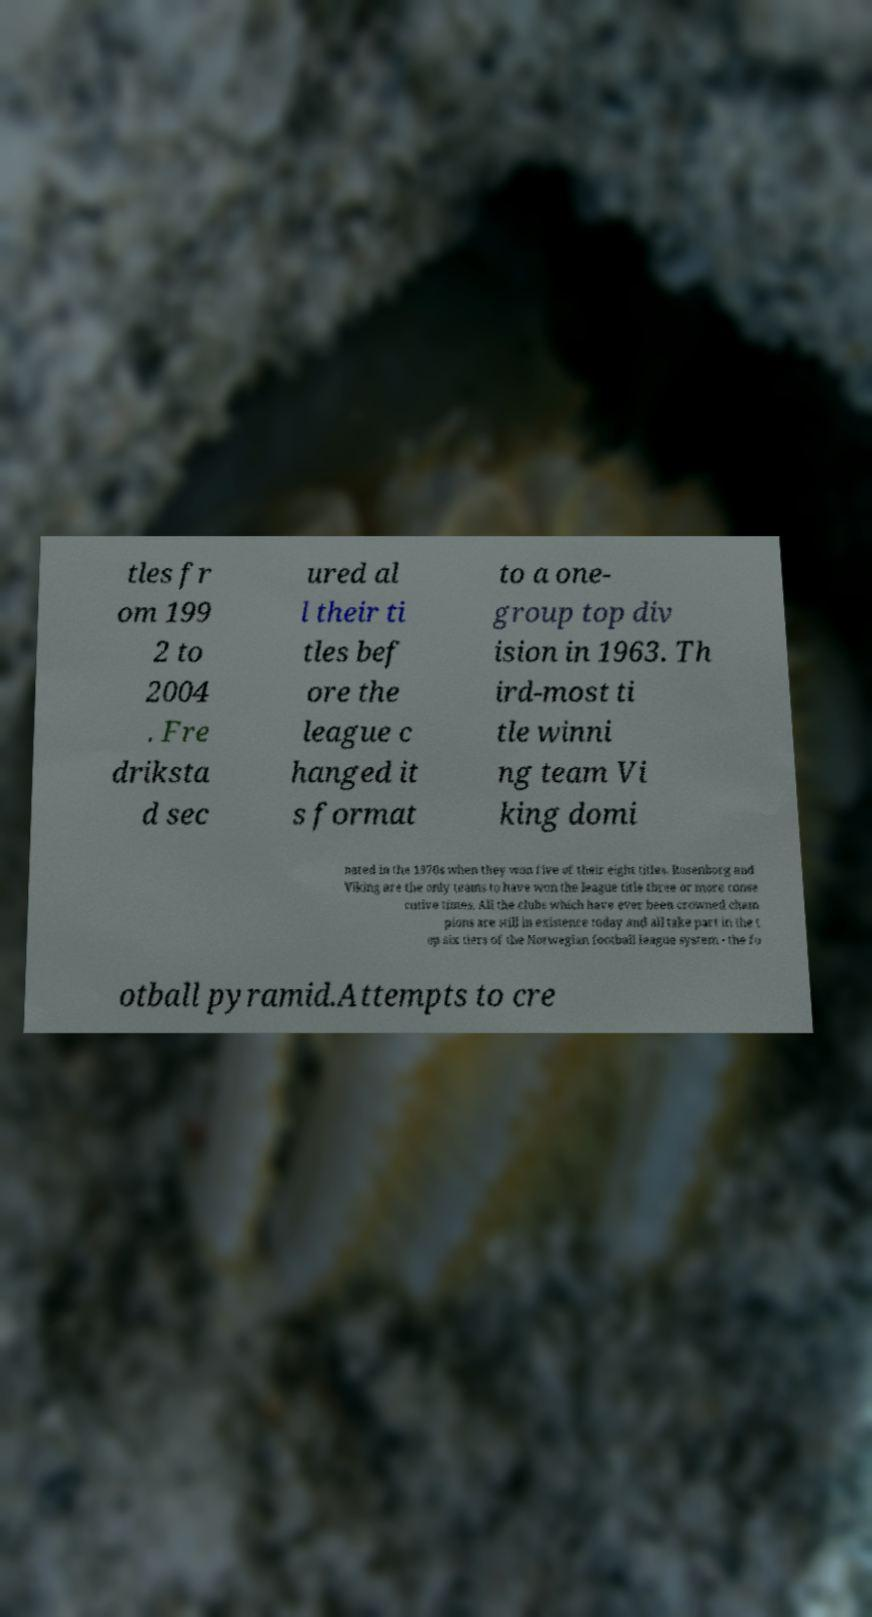For documentation purposes, I need the text within this image transcribed. Could you provide that? tles fr om 199 2 to 2004 . Fre driksta d sec ured al l their ti tles bef ore the league c hanged it s format to a one- group top div ision in 1963. Th ird-most ti tle winni ng team Vi king domi nated in the 1970s when they won five of their eight titles. Rosenborg and Viking are the only teams to have won the league title three or more conse cutive times. All the clubs which have ever been crowned cham pions are still in existence today and all take part in the t op six tiers of the Norwegian football league system - the fo otball pyramid.Attempts to cre 